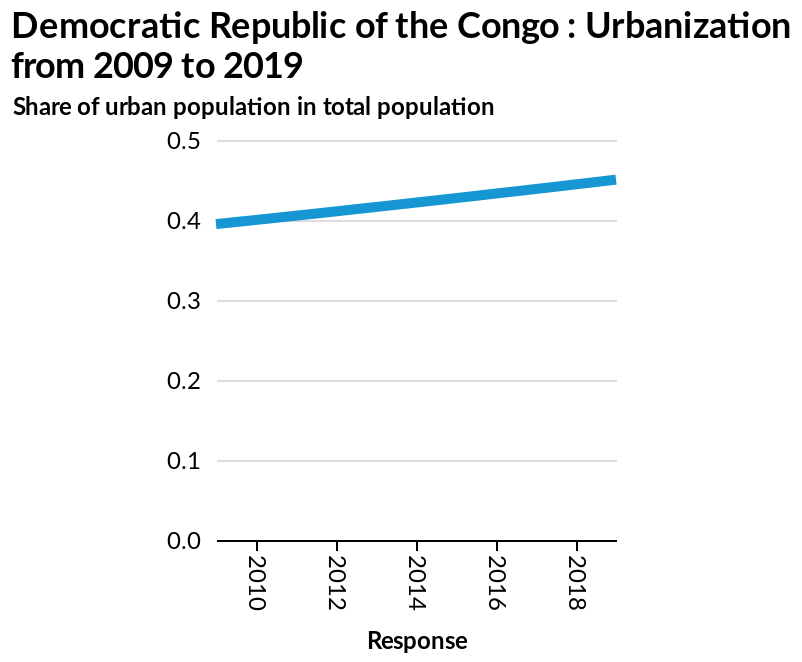<image>
Offer a thorough analysis of the image. This shows that the urban population has increased slightly over 10 yearsThe increase only starts in 2012. 